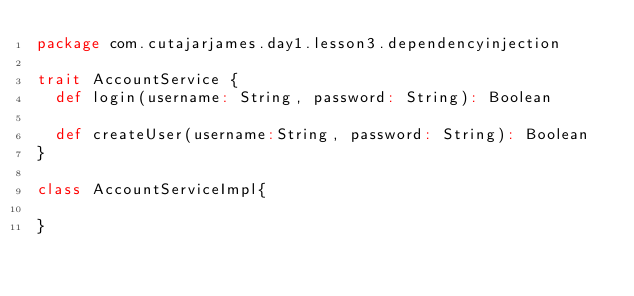<code> <loc_0><loc_0><loc_500><loc_500><_Scala_>package com.cutajarjames.day1.lesson3.dependencyinjection

trait AccountService {
  def login(username: String, password: String): Boolean

  def createUser(username:String, password: String): Boolean
}

class AccountServiceImpl{

}</code> 